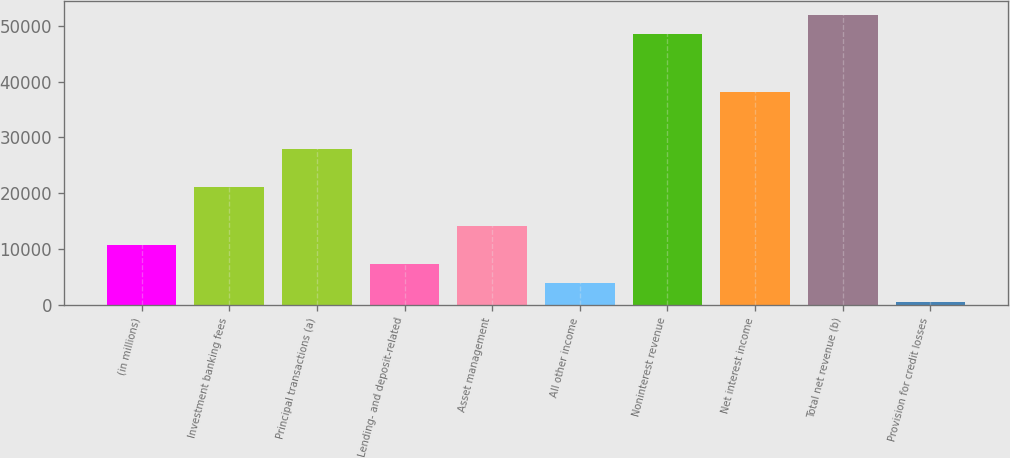Convert chart to OTSL. <chart><loc_0><loc_0><loc_500><loc_500><bar_chart><fcel>(in millions)<fcel>Investment banking fees<fcel>Principal transactions (a)<fcel>Lending- and deposit-related<fcel>Asset management<fcel>All other income<fcel>Noninterest revenue<fcel>Net interest income<fcel>Total net revenue (b)<fcel>Provision for credit losses<nl><fcel>10763.9<fcel>21048.8<fcel>27905.4<fcel>7335.6<fcel>14192.2<fcel>3907.3<fcel>48475.2<fcel>38190.3<fcel>51903.5<fcel>479<nl></chart> 